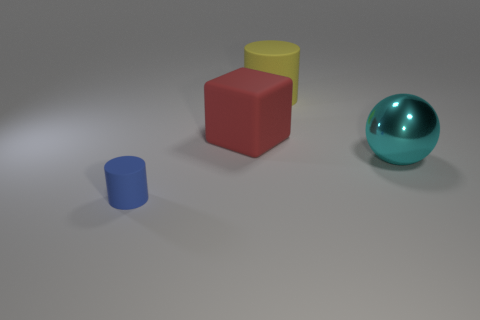What is the size of the object that is left of the cyan ball and in front of the red thing? The object to the left of the cyan ball and in front of the red cube is a small blue cylinder. 